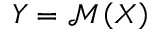<formula> <loc_0><loc_0><loc_500><loc_500>Y = \mathcal { M } \left ( X \right )</formula> 